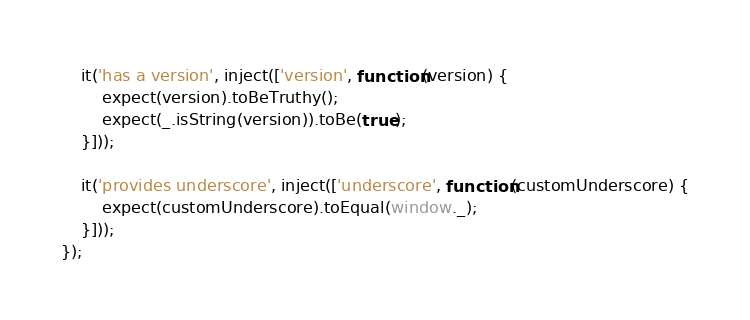<code> <loc_0><loc_0><loc_500><loc_500><_JavaScript_>	it('has a version', inject(['version', function(version) {
		expect(version).toBeTruthy();
		expect(_.isString(version)).toBe(true);
	}]));

	it('provides underscore', inject(['underscore', function(customUnderscore) {
		expect(customUnderscore).toEqual(window._);
	}]));
});</code> 